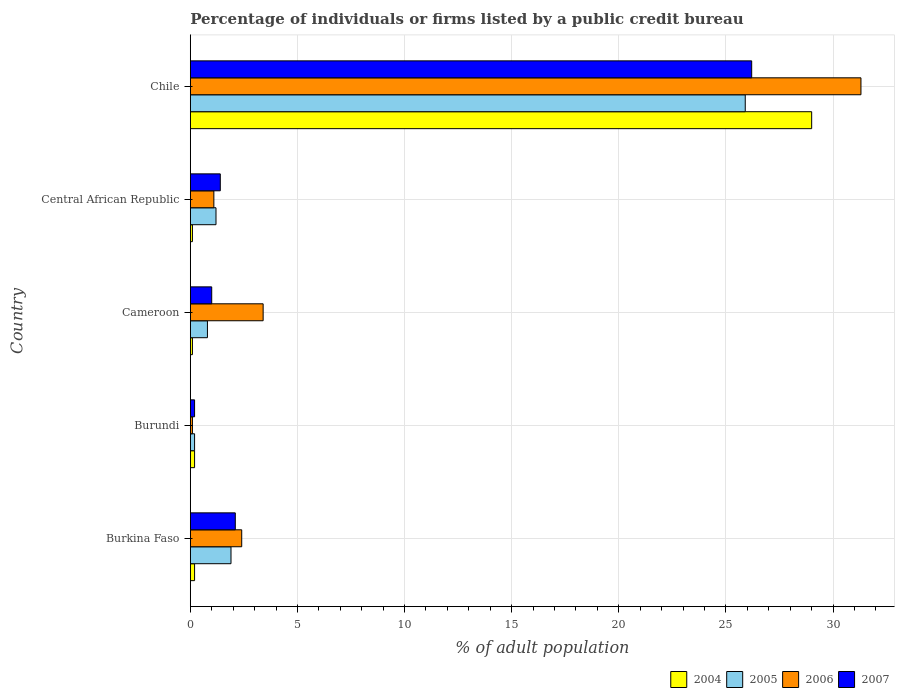How many groups of bars are there?
Your response must be concise. 5. Are the number of bars on each tick of the Y-axis equal?
Provide a succinct answer. Yes. How many bars are there on the 5th tick from the top?
Your response must be concise. 4. How many bars are there on the 2nd tick from the bottom?
Ensure brevity in your answer.  4. What is the label of the 3rd group of bars from the top?
Your response must be concise. Cameroon. What is the percentage of population listed by a public credit bureau in 2007 in Cameroon?
Provide a short and direct response. 1. Across all countries, what is the maximum percentage of population listed by a public credit bureau in 2005?
Provide a succinct answer. 25.9. Across all countries, what is the minimum percentage of population listed by a public credit bureau in 2004?
Ensure brevity in your answer.  0.1. In which country was the percentage of population listed by a public credit bureau in 2006 maximum?
Offer a very short reply. Chile. In which country was the percentage of population listed by a public credit bureau in 2006 minimum?
Give a very brief answer. Burundi. What is the total percentage of population listed by a public credit bureau in 2007 in the graph?
Offer a very short reply. 30.9. What is the difference between the percentage of population listed by a public credit bureau in 2004 in Central African Republic and that in Chile?
Provide a short and direct response. -28.9. What is the difference between the percentage of population listed by a public credit bureau in 2004 in Cameroon and the percentage of population listed by a public credit bureau in 2007 in Central African Republic?
Your response must be concise. -1.3. What is the average percentage of population listed by a public credit bureau in 2006 per country?
Offer a very short reply. 7.66. What is the difference between the percentage of population listed by a public credit bureau in 2004 and percentage of population listed by a public credit bureau in 2007 in Chile?
Provide a succinct answer. 2.8. In how many countries, is the percentage of population listed by a public credit bureau in 2005 greater than 22 %?
Your answer should be very brief. 1. What is the ratio of the percentage of population listed by a public credit bureau in 2005 in Cameroon to that in Central African Republic?
Provide a short and direct response. 0.67. Is the difference between the percentage of population listed by a public credit bureau in 2004 in Burundi and Chile greater than the difference between the percentage of population listed by a public credit bureau in 2007 in Burundi and Chile?
Offer a terse response. No. What is the difference between the highest and the second highest percentage of population listed by a public credit bureau in 2006?
Offer a terse response. 27.9. What is the difference between the highest and the lowest percentage of population listed by a public credit bureau in 2004?
Offer a terse response. 28.9. Is the sum of the percentage of population listed by a public credit bureau in 2004 in Burkina Faso and Central African Republic greater than the maximum percentage of population listed by a public credit bureau in 2006 across all countries?
Your answer should be compact. No. What does the 1st bar from the bottom in Central African Republic represents?
Offer a terse response. 2004. Is it the case that in every country, the sum of the percentage of population listed by a public credit bureau in 2004 and percentage of population listed by a public credit bureau in 2005 is greater than the percentage of population listed by a public credit bureau in 2006?
Ensure brevity in your answer.  No. Are all the bars in the graph horizontal?
Give a very brief answer. Yes. How many countries are there in the graph?
Your response must be concise. 5. What is the difference between two consecutive major ticks on the X-axis?
Provide a short and direct response. 5. Are the values on the major ticks of X-axis written in scientific E-notation?
Ensure brevity in your answer.  No. How are the legend labels stacked?
Keep it short and to the point. Horizontal. What is the title of the graph?
Provide a short and direct response. Percentage of individuals or firms listed by a public credit bureau. Does "1970" appear as one of the legend labels in the graph?
Provide a succinct answer. No. What is the label or title of the X-axis?
Your response must be concise. % of adult population. What is the % of adult population of 2004 in Burkina Faso?
Keep it short and to the point. 0.2. What is the % of adult population in 2005 in Burkina Faso?
Offer a very short reply. 1.9. What is the % of adult population in 2006 in Burkina Faso?
Keep it short and to the point. 2.4. What is the % of adult population of 2004 in Burundi?
Ensure brevity in your answer.  0.2. What is the % of adult population of 2005 in Burundi?
Your response must be concise. 0.2. What is the % of adult population in 2006 in Burundi?
Your answer should be compact. 0.1. What is the % of adult population of 2007 in Burundi?
Keep it short and to the point. 0.2. What is the % of adult population in 2004 in Cameroon?
Your answer should be compact. 0.1. What is the % of adult population in 2005 in Cameroon?
Your response must be concise. 0.8. What is the % of adult population of 2006 in Cameroon?
Ensure brevity in your answer.  3.4. What is the % of adult population in 2007 in Cameroon?
Your answer should be compact. 1. What is the % of adult population of 2004 in Central African Republic?
Make the answer very short. 0.1. What is the % of adult population in 2005 in Central African Republic?
Make the answer very short. 1.2. What is the % of adult population in 2005 in Chile?
Provide a short and direct response. 25.9. What is the % of adult population in 2006 in Chile?
Offer a terse response. 31.3. What is the % of adult population of 2007 in Chile?
Ensure brevity in your answer.  26.2. Across all countries, what is the maximum % of adult population in 2005?
Give a very brief answer. 25.9. Across all countries, what is the maximum % of adult population in 2006?
Ensure brevity in your answer.  31.3. Across all countries, what is the maximum % of adult population in 2007?
Ensure brevity in your answer.  26.2. Across all countries, what is the minimum % of adult population of 2007?
Provide a short and direct response. 0.2. What is the total % of adult population in 2004 in the graph?
Provide a succinct answer. 29.6. What is the total % of adult population of 2005 in the graph?
Offer a very short reply. 30. What is the total % of adult population of 2006 in the graph?
Offer a very short reply. 38.3. What is the total % of adult population in 2007 in the graph?
Provide a short and direct response. 30.9. What is the difference between the % of adult population in 2004 in Burkina Faso and that in Burundi?
Offer a very short reply. 0. What is the difference between the % of adult population in 2006 in Burkina Faso and that in Burundi?
Keep it short and to the point. 2.3. What is the difference between the % of adult population in 2004 in Burkina Faso and that in Cameroon?
Your response must be concise. 0.1. What is the difference between the % of adult population of 2007 in Burkina Faso and that in Cameroon?
Give a very brief answer. 1.1. What is the difference between the % of adult population in 2006 in Burkina Faso and that in Central African Republic?
Your answer should be very brief. 1.3. What is the difference between the % of adult population of 2004 in Burkina Faso and that in Chile?
Provide a short and direct response. -28.8. What is the difference between the % of adult population of 2006 in Burkina Faso and that in Chile?
Ensure brevity in your answer.  -28.9. What is the difference between the % of adult population in 2007 in Burkina Faso and that in Chile?
Make the answer very short. -24.1. What is the difference between the % of adult population in 2004 in Burundi and that in Cameroon?
Offer a terse response. 0.1. What is the difference between the % of adult population of 2005 in Burundi and that in Cameroon?
Offer a terse response. -0.6. What is the difference between the % of adult population in 2007 in Burundi and that in Cameroon?
Your answer should be compact. -0.8. What is the difference between the % of adult population in 2005 in Burundi and that in Central African Republic?
Your answer should be very brief. -1. What is the difference between the % of adult population of 2006 in Burundi and that in Central African Republic?
Your response must be concise. -1. What is the difference between the % of adult population of 2007 in Burundi and that in Central African Republic?
Your answer should be very brief. -1.2. What is the difference between the % of adult population of 2004 in Burundi and that in Chile?
Keep it short and to the point. -28.8. What is the difference between the % of adult population of 2005 in Burundi and that in Chile?
Offer a terse response. -25.7. What is the difference between the % of adult population in 2006 in Burundi and that in Chile?
Keep it short and to the point. -31.2. What is the difference between the % of adult population of 2007 in Burundi and that in Chile?
Keep it short and to the point. -26. What is the difference between the % of adult population in 2006 in Cameroon and that in Central African Republic?
Give a very brief answer. 2.3. What is the difference between the % of adult population in 2007 in Cameroon and that in Central African Republic?
Your answer should be compact. -0.4. What is the difference between the % of adult population in 2004 in Cameroon and that in Chile?
Your answer should be compact. -28.9. What is the difference between the % of adult population in 2005 in Cameroon and that in Chile?
Your response must be concise. -25.1. What is the difference between the % of adult population of 2006 in Cameroon and that in Chile?
Provide a short and direct response. -27.9. What is the difference between the % of adult population in 2007 in Cameroon and that in Chile?
Offer a terse response. -25.2. What is the difference between the % of adult population in 2004 in Central African Republic and that in Chile?
Make the answer very short. -28.9. What is the difference between the % of adult population of 2005 in Central African Republic and that in Chile?
Offer a terse response. -24.7. What is the difference between the % of adult population of 2006 in Central African Republic and that in Chile?
Make the answer very short. -30.2. What is the difference between the % of adult population in 2007 in Central African Republic and that in Chile?
Provide a short and direct response. -24.8. What is the difference between the % of adult population of 2004 in Burkina Faso and the % of adult population of 2005 in Burundi?
Make the answer very short. 0. What is the difference between the % of adult population in 2005 in Burkina Faso and the % of adult population in 2006 in Burundi?
Offer a very short reply. 1.8. What is the difference between the % of adult population of 2006 in Burkina Faso and the % of adult population of 2007 in Burundi?
Offer a very short reply. 2.2. What is the difference between the % of adult population in 2004 in Burkina Faso and the % of adult population in 2005 in Cameroon?
Your answer should be compact. -0.6. What is the difference between the % of adult population in 2004 in Burkina Faso and the % of adult population in 2006 in Cameroon?
Your answer should be very brief. -3.2. What is the difference between the % of adult population in 2004 in Burkina Faso and the % of adult population in 2007 in Cameroon?
Offer a very short reply. -0.8. What is the difference between the % of adult population in 2004 in Burkina Faso and the % of adult population in 2007 in Central African Republic?
Offer a terse response. -1.2. What is the difference between the % of adult population in 2004 in Burkina Faso and the % of adult population in 2005 in Chile?
Your answer should be compact. -25.7. What is the difference between the % of adult population in 2004 in Burkina Faso and the % of adult population in 2006 in Chile?
Give a very brief answer. -31.1. What is the difference between the % of adult population in 2004 in Burkina Faso and the % of adult population in 2007 in Chile?
Make the answer very short. -26. What is the difference between the % of adult population of 2005 in Burkina Faso and the % of adult population of 2006 in Chile?
Provide a succinct answer. -29.4. What is the difference between the % of adult population in 2005 in Burkina Faso and the % of adult population in 2007 in Chile?
Give a very brief answer. -24.3. What is the difference between the % of adult population in 2006 in Burkina Faso and the % of adult population in 2007 in Chile?
Your answer should be compact. -23.8. What is the difference between the % of adult population in 2004 in Burundi and the % of adult population in 2006 in Cameroon?
Your answer should be very brief. -3.2. What is the difference between the % of adult population in 2004 in Burundi and the % of adult population in 2007 in Cameroon?
Your answer should be compact. -0.8. What is the difference between the % of adult population of 2005 in Burundi and the % of adult population of 2006 in Cameroon?
Your response must be concise. -3.2. What is the difference between the % of adult population of 2004 in Burundi and the % of adult population of 2007 in Central African Republic?
Offer a terse response. -1.2. What is the difference between the % of adult population of 2005 in Burundi and the % of adult population of 2006 in Central African Republic?
Provide a succinct answer. -0.9. What is the difference between the % of adult population of 2004 in Burundi and the % of adult population of 2005 in Chile?
Make the answer very short. -25.7. What is the difference between the % of adult population in 2004 in Burundi and the % of adult population in 2006 in Chile?
Ensure brevity in your answer.  -31.1. What is the difference between the % of adult population in 2005 in Burundi and the % of adult population in 2006 in Chile?
Keep it short and to the point. -31.1. What is the difference between the % of adult population of 2006 in Burundi and the % of adult population of 2007 in Chile?
Provide a succinct answer. -26.1. What is the difference between the % of adult population in 2004 in Cameroon and the % of adult population in 2005 in Central African Republic?
Keep it short and to the point. -1.1. What is the difference between the % of adult population of 2004 in Cameroon and the % of adult population of 2006 in Central African Republic?
Your answer should be compact. -1. What is the difference between the % of adult population of 2005 in Cameroon and the % of adult population of 2007 in Central African Republic?
Keep it short and to the point. -0.6. What is the difference between the % of adult population of 2004 in Cameroon and the % of adult population of 2005 in Chile?
Make the answer very short. -25.8. What is the difference between the % of adult population in 2004 in Cameroon and the % of adult population in 2006 in Chile?
Ensure brevity in your answer.  -31.2. What is the difference between the % of adult population in 2004 in Cameroon and the % of adult population in 2007 in Chile?
Ensure brevity in your answer.  -26.1. What is the difference between the % of adult population of 2005 in Cameroon and the % of adult population of 2006 in Chile?
Offer a terse response. -30.5. What is the difference between the % of adult population of 2005 in Cameroon and the % of adult population of 2007 in Chile?
Give a very brief answer. -25.4. What is the difference between the % of adult population in 2006 in Cameroon and the % of adult population in 2007 in Chile?
Your response must be concise. -22.8. What is the difference between the % of adult population of 2004 in Central African Republic and the % of adult population of 2005 in Chile?
Ensure brevity in your answer.  -25.8. What is the difference between the % of adult population of 2004 in Central African Republic and the % of adult population of 2006 in Chile?
Make the answer very short. -31.2. What is the difference between the % of adult population of 2004 in Central African Republic and the % of adult population of 2007 in Chile?
Give a very brief answer. -26.1. What is the difference between the % of adult population of 2005 in Central African Republic and the % of adult population of 2006 in Chile?
Your answer should be very brief. -30.1. What is the difference between the % of adult population in 2006 in Central African Republic and the % of adult population in 2007 in Chile?
Your answer should be very brief. -25.1. What is the average % of adult population in 2004 per country?
Offer a very short reply. 5.92. What is the average % of adult population of 2006 per country?
Offer a terse response. 7.66. What is the average % of adult population of 2007 per country?
Offer a very short reply. 6.18. What is the difference between the % of adult population in 2004 and % of adult population in 2005 in Burkina Faso?
Make the answer very short. -1.7. What is the difference between the % of adult population of 2004 and % of adult population of 2007 in Burkina Faso?
Your answer should be compact. -1.9. What is the difference between the % of adult population of 2006 and % of adult population of 2007 in Burkina Faso?
Keep it short and to the point. 0.3. What is the difference between the % of adult population of 2004 and % of adult population of 2005 in Burundi?
Give a very brief answer. 0. What is the difference between the % of adult population of 2004 and % of adult population of 2006 in Burundi?
Offer a terse response. 0.1. What is the difference between the % of adult population of 2005 and % of adult population of 2006 in Burundi?
Provide a succinct answer. 0.1. What is the difference between the % of adult population of 2005 and % of adult population of 2007 in Burundi?
Your answer should be compact. 0. What is the difference between the % of adult population of 2004 and % of adult population of 2005 in Cameroon?
Make the answer very short. -0.7. What is the difference between the % of adult population in 2004 and % of adult population in 2006 in Cameroon?
Keep it short and to the point. -3.3. What is the difference between the % of adult population in 2005 and % of adult population in 2006 in Cameroon?
Ensure brevity in your answer.  -2.6. What is the difference between the % of adult population in 2006 and % of adult population in 2007 in Cameroon?
Make the answer very short. 2.4. What is the difference between the % of adult population in 2004 and % of adult population in 2006 in Central African Republic?
Ensure brevity in your answer.  -1. What is the difference between the % of adult population in 2005 and % of adult population in 2006 in Central African Republic?
Ensure brevity in your answer.  0.1. What is the difference between the % of adult population of 2005 and % of adult population of 2007 in Central African Republic?
Ensure brevity in your answer.  -0.2. What is the difference between the % of adult population in 2004 and % of adult population in 2006 in Chile?
Ensure brevity in your answer.  -2.3. What is the difference between the % of adult population in 2004 and % of adult population in 2007 in Chile?
Give a very brief answer. 2.8. What is the difference between the % of adult population in 2005 and % of adult population in 2007 in Chile?
Offer a terse response. -0.3. What is the ratio of the % of adult population of 2006 in Burkina Faso to that in Burundi?
Give a very brief answer. 24. What is the ratio of the % of adult population of 2007 in Burkina Faso to that in Burundi?
Provide a succinct answer. 10.5. What is the ratio of the % of adult population of 2004 in Burkina Faso to that in Cameroon?
Your response must be concise. 2. What is the ratio of the % of adult population in 2005 in Burkina Faso to that in Cameroon?
Ensure brevity in your answer.  2.38. What is the ratio of the % of adult population of 2006 in Burkina Faso to that in Cameroon?
Provide a succinct answer. 0.71. What is the ratio of the % of adult population of 2007 in Burkina Faso to that in Cameroon?
Keep it short and to the point. 2.1. What is the ratio of the % of adult population in 2005 in Burkina Faso to that in Central African Republic?
Give a very brief answer. 1.58. What is the ratio of the % of adult population in 2006 in Burkina Faso to that in Central African Republic?
Provide a succinct answer. 2.18. What is the ratio of the % of adult population of 2004 in Burkina Faso to that in Chile?
Your response must be concise. 0.01. What is the ratio of the % of adult population of 2005 in Burkina Faso to that in Chile?
Provide a succinct answer. 0.07. What is the ratio of the % of adult population of 2006 in Burkina Faso to that in Chile?
Make the answer very short. 0.08. What is the ratio of the % of adult population in 2007 in Burkina Faso to that in Chile?
Offer a terse response. 0.08. What is the ratio of the % of adult population of 2006 in Burundi to that in Cameroon?
Ensure brevity in your answer.  0.03. What is the ratio of the % of adult population of 2007 in Burundi to that in Cameroon?
Your response must be concise. 0.2. What is the ratio of the % of adult population of 2006 in Burundi to that in Central African Republic?
Give a very brief answer. 0.09. What is the ratio of the % of adult population in 2007 in Burundi to that in Central African Republic?
Provide a short and direct response. 0.14. What is the ratio of the % of adult population in 2004 in Burundi to that in Chile?
Your answer should be very brief. 0.01. What is the ratio of the % of adult population in 2005 in Burundi to that in Chile?
Provide a short and direct response. 0.01. What is the ratio of the % of adult population of 2006 in Burundi to that in Chile?
Provide a succinct answer. 0. What is the ratio of the % of adult population in 2007 in Burundi to that in Chile?
Offer a terse response. 0.01. What is the ratio of the % of adult population in 2006 in Cameroon to that in Central African Republic?
Your answer should be compact. 3.09. What is the ratio of the % of adult population of 2007 in Cameroon to that in Central African Republic?
Your answer should be compact. 0.71. What is the ratio of the % of adult population of 2004 in Cameroon to that in Chile?
Offer a terse response. 0. What is the ratio of the % of adult population of 2005 in Cameroon to that in Chile?
Your answer should be compact. 0.03. What is the ratio of the % of adult population of 2006 in Cameroon to that in Chile?
Make the answer very short. 0.11. What is the ratio of the % of adult population in 2007 in Cameroon to that in Chile?
Offer a very short reply. 0.04. What is the ratio of the % of adult population in 2004 in Central African Republic to that in Chile?
Offer a terse response. 0. What is the ratio of the % of adult population in 2005 in Central African Republic to that in Chile?
Your response must be concise. 0.05. What is the ratio of the % of adult population of 2006 in Central African Republic to that in Chile?
Provide a short and direct response. 0.04. What is the ratio of the % of adult population of 2007 in Central African Republic to that in Chile?
Provide a short and direct response. 0.05. What is the difference between the highest and the second highest % of adult population of 2004?
Your answer should be very brief. 28.8. What is the difference between the highest and the second highest % of adult population in 2006?
Keep it short and to the point. 27.9. What is the difference between the highest and the second highest % of adult population of 2007?
Provide a short and direct response. 24.1. What is the difference between the highest and the lowest % of adult population of 2004?
Provide a short and direct response. 28.9. What is the difference between the highest and the lowest % of adult population in 2005?
Your response must be concise. 25.7. What is the difference between the highest and the lowest % of adult population in 2006?
Your answer should be very brief. 31.2. What is the difference between the highest and the lowest % of adult population in 2007?
Provide a short and direct response. 26. 